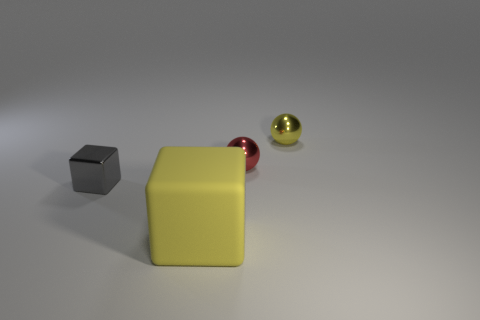Add 3 gray metal blocks. How many objects exist? 7 Subtract 0 brown cylinders. How many objects are left? 4 Subtract all purple cylinders. Subtract all yellow metal balls. How many objects are left? 3 Add 4 small metal blocks. How many small metal blocks are left? 5 Add 1 large yellow cubes. How many large yellow cubes exist? 2 